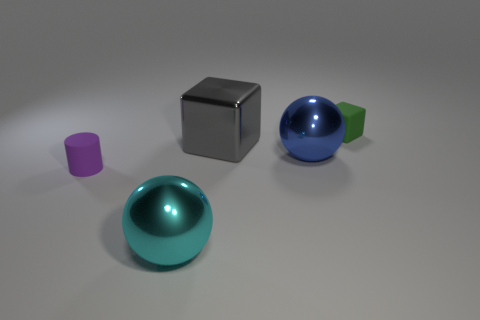Subtract 1 cubes. How many cubes are left? 1 Add 5 large red matte things. How many objects exist? 10 Subtract 0 gray balls. How many objects are left? 5 Subtract all blocks. How many objects are left? 3 Subtract all purple blocks. Subtract all gray cylinders. How many blocks are left? 2 Subtract all gray cylinders. How many cyan spheres are left? 1 Subtract all tiny green cylinders. Subtract all small green objects. How many objects are left? 4 Add 3 green matte objects. How many green matte objects are left? 4 Add 2 big gray blocks. How many big gray blocks exist? 3 Subtract all blue balls. How many balls are left? 1 